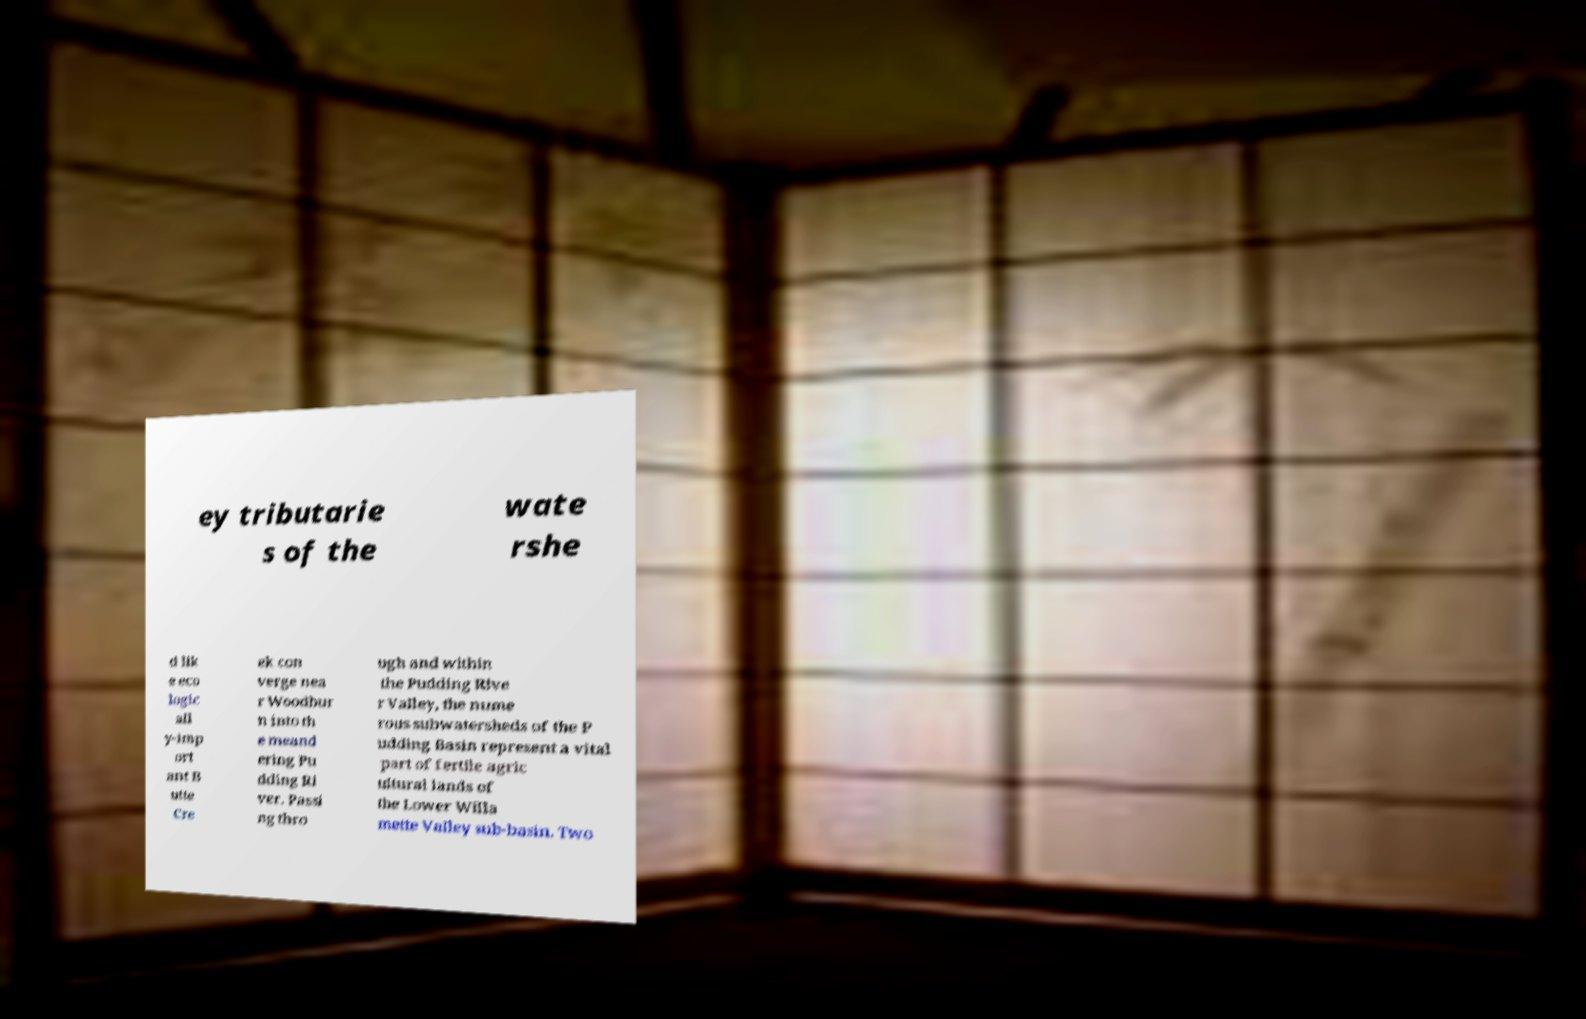Can you read and provide the text displayed in the image?This photo seems to have some interesting text. Can you extract and type it out for me? ey tributarie s of the wate rshe d lik e eco logic all y-imp ort ant B utte Cre ek con verge nea r Woodbur n into th e meand ering Pu dding Ri ver. Passi ng thro ugh and within the Pudding Rive r Valley, the nume rous subwatersheds of the P udding Basin represent a vital part of fertile agric ultural lands of the Lower Willa mette Valley sub-basin. Two 